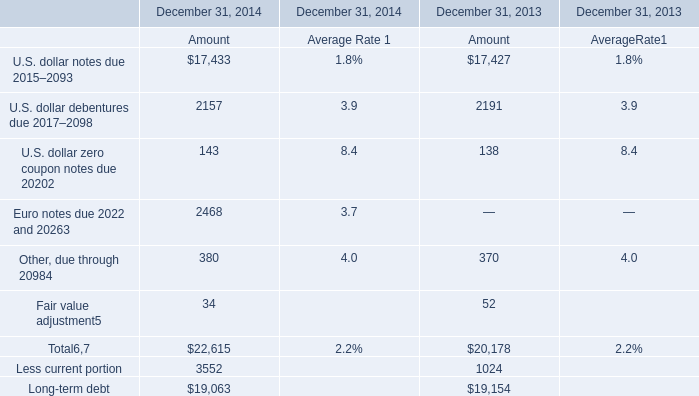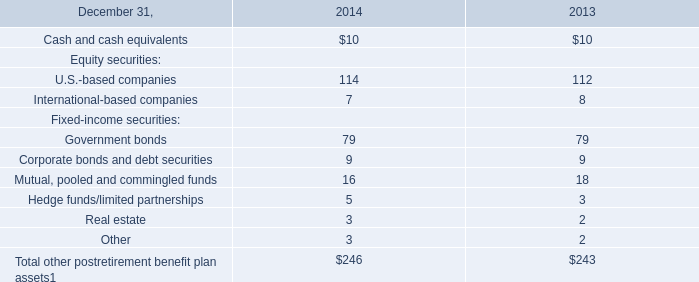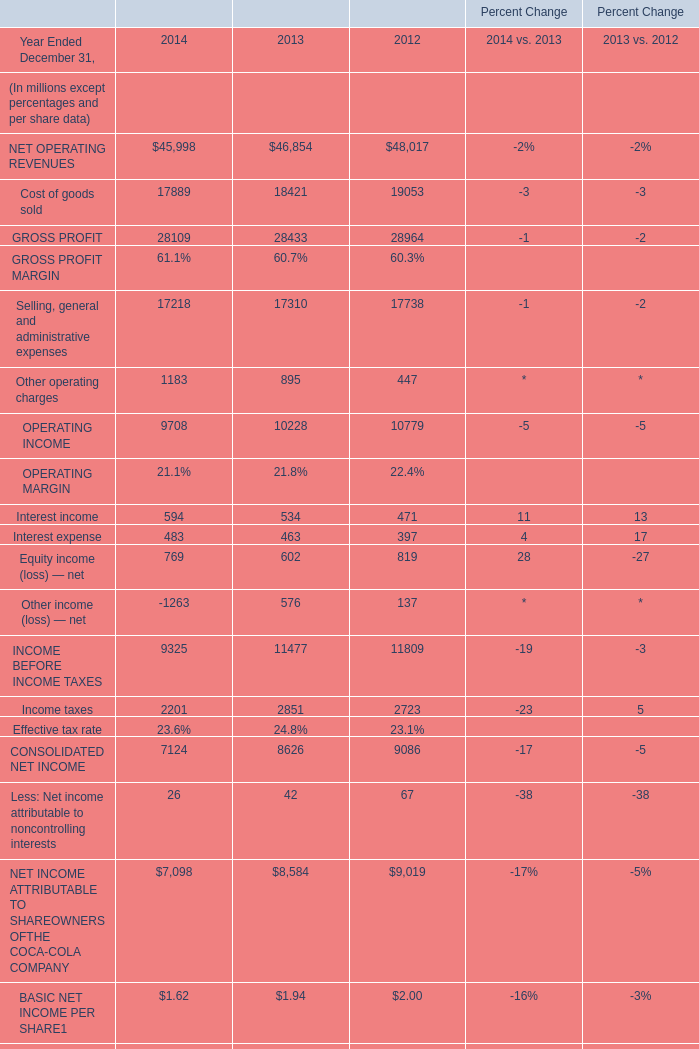What is the sum of Income taxes of Percent Change 2012, and U.S. dollar debentures due 2017–2098 of December 31, 2013 Amount ? 
Computations: (2723.0 + 2191.0)
Answer: 4914.0. 